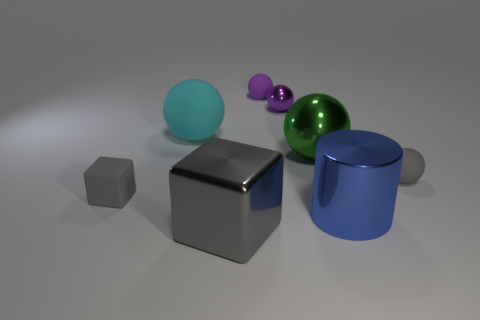Subtract all tiny purple metallic balls. How many balls are left? 4 Subtract all gray spheres. How many spheres are left? 4 Subtract 1 blocks. How many blocks are left? 1 Subtract all blocks. How many objects are left? 6 Add 1 big metal balls. How many objects exist? 9 Subtract all metallic balls. Subtract all large metallic balls. How many objects are left? 5 Add 1 large blue objects. How many large blue objects are left? 2 Add 4 small matte balls. How many small matte balls exist? 6 Subtract 0 yellow cylinders. How many objects are left? 8 Subtract all purple cylinders. Subtract all red blocks. How many cylinders are left? 1 